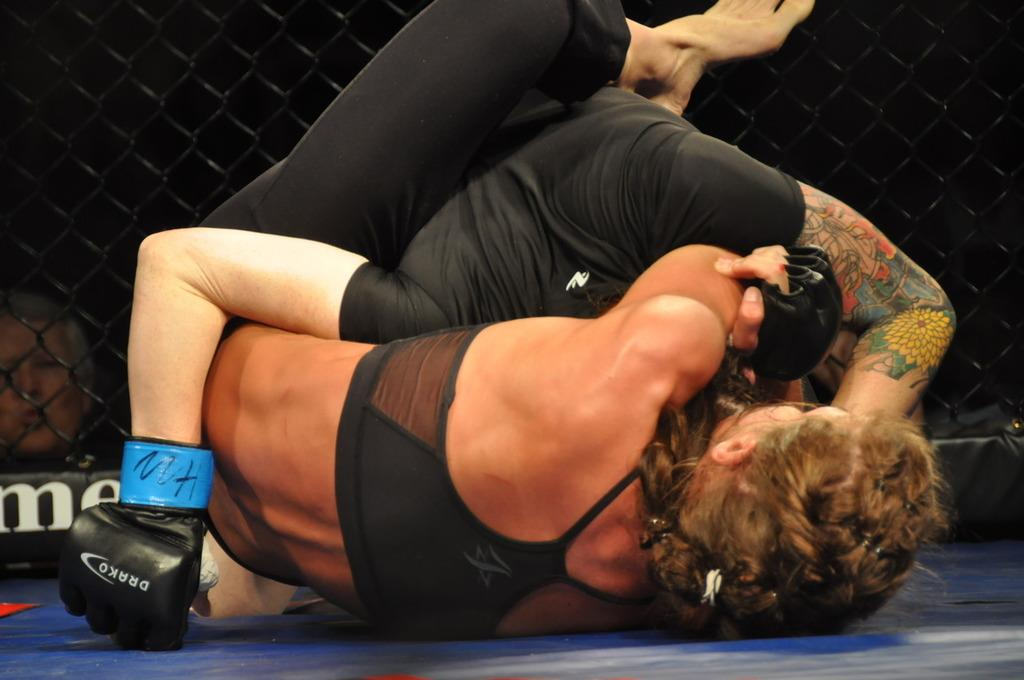<image>
Share a concise interpretation of the image provided. A person wearing Drako boxing gloves wrestles a woman. 